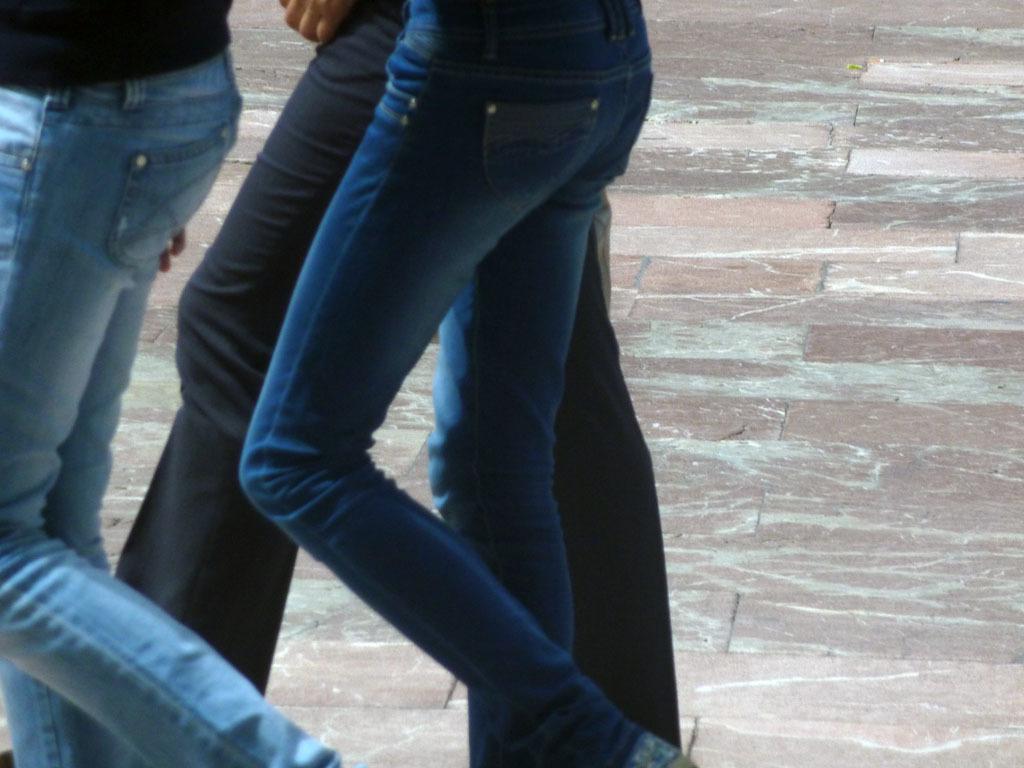Please provide a concise description of this image. In this image I can see three persons walking and they are wearing blue color jeans. The floor is in multi color. 